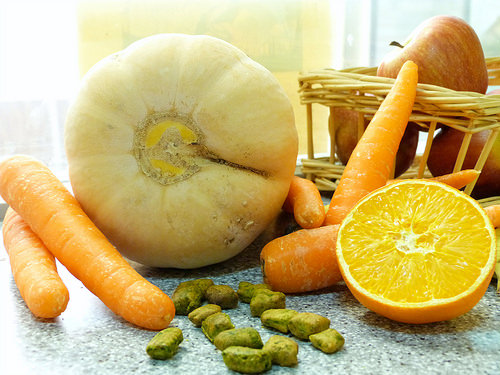<image>
Is there a carrot in front of the orange? No. The carrot is not in front of the orange. The spatial positioning shows a different relationship between these objects. 